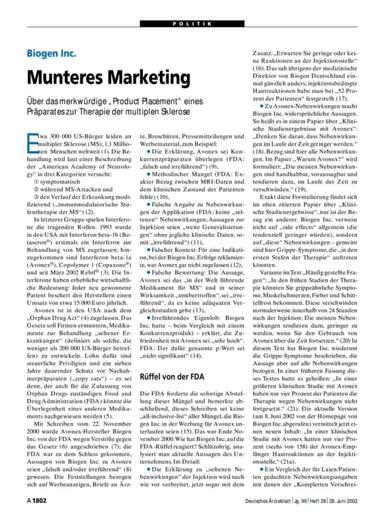What is the approximate number of people suffering from multiple sclerosis mentioned in the text? The document specifics that approximately 300,000 individuals globally are affected by multiple sclerosis, underlining the significant impact of this condition on the global population. 